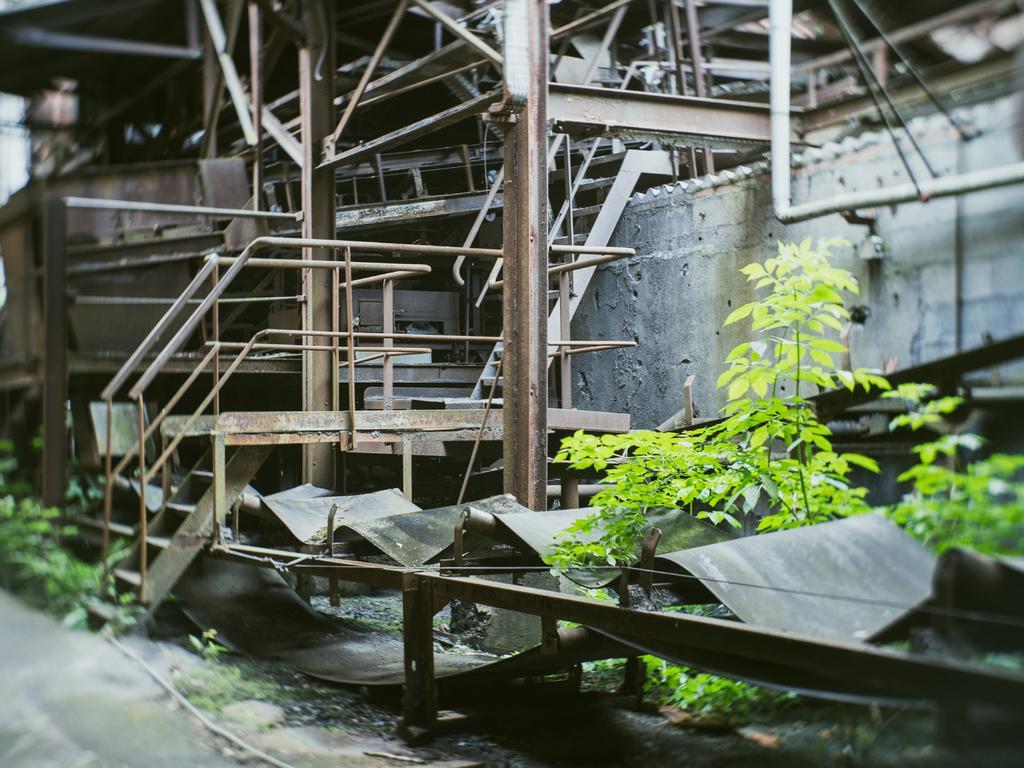Can you describe this image briefly? In this image there are plants on the land. Middle of the image there is a staircase. Right side there is a wall. Background there are metal objects. Bottom of the image there is a fence having metal object. 